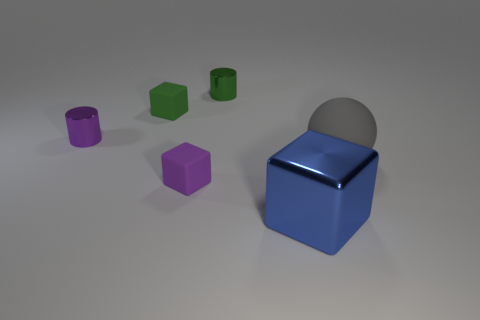What is the shape of the small rubber object that is in front of the rubber cube behind the rubber object to the right of the large blue shiny object?
Give a very brief answer. Cube. How many brown objects are either tiny cylinders or big spheres?
Provide a short and direct response. 0. Are there the same number of small purple objects that are behind the sphere and purple cylinders that are to the right of the green matte block?
Offer a very short reply. No. There is a green thing that is in front of the small green metal cylinder; is its shape the same as the large blue shiny thing right of the purple rubber block?
Provide a short and direct response. Yes. Are there any other things that are the same shape as the gray thing?
Your answer should be compact. No. The tiny purple object that is the same material as the large blue cube is what shape?
Provide a short and direct response. Cylinder. Is the number of tiny purple rubber things behind the tiny green cube the same as the number of small green blocks?
Ensure brevity in your answer.  No. Does the large object to the left of the large gray matte object have the same material as the small block that is right of the green matte block?
Offer a very short reply. No. The purple thing that is to the left of the small purple thing to the right of the tiny purple metal object is what shape?
Provide a short and direct response. Cylinder. What color is the big thing that is the same material as the green cube?
Ensure brevity in your answer.  Gray. 